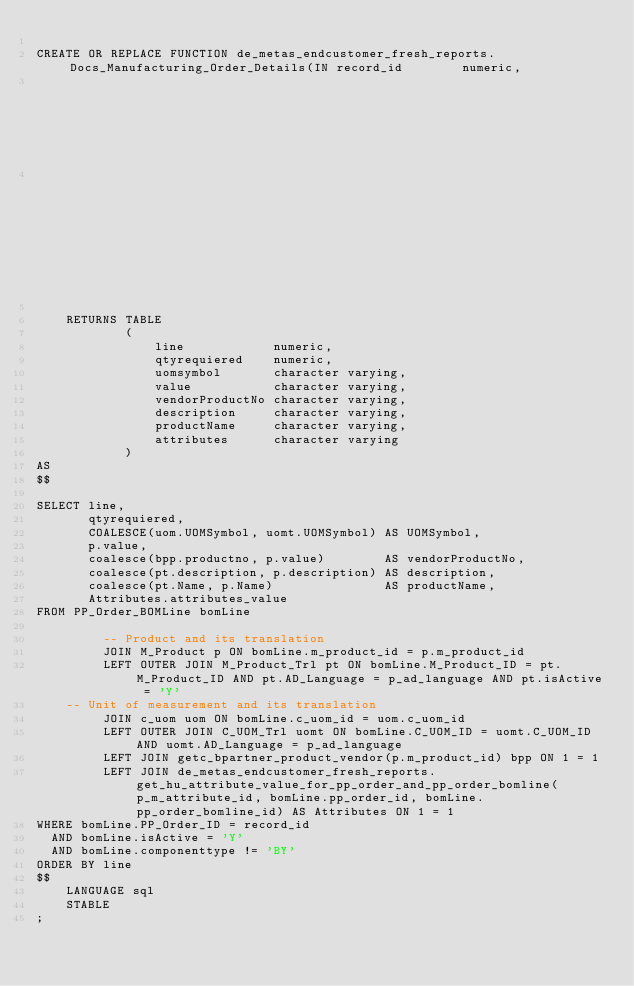<code> <loc_0><loc_0><loc_500><loc_500><_SQL_>
CREATE OR REPLACE FUNCTION de_metas_endcustomer_fresh_reports.Docs_Manufacturing_Order_Details(IN record_id        numeric,
                                                                                               IN p_m_attribute_id numeric,
                                                                                               IN p_ad_language    character Varying)

    RETURNS TABLE
            (
                line            numeric,
                qtyrequiered    numeric,
                uomsymbol       character varying,
                value           character varying,
                vendorProductNo character varying,
                description     character varying,
                productName     character varying,
                attributes      character varying
            )
AS
$$

SELECT line,
       qtyrequiered,
       COALESCE(uom.UOMSymbol, uomt.UOMSymbol) AS UOMSymbol,
       p.value,
       coalesce(bpp.productno, p.value)        AS vendorProductNo,
       coalesce(pt.description, p.description) AS description,
       coalesce(pt.Name, p.Name)               AS productName,
       Attributes.attributes_value
FROM PP_Order_BOMLine bomLine

         -- Product and its translation
         JOIN M_Product p ON bomLine.m_product_id = p.m_product_id
         LEFT OUTER JOIN M_Product_Trl pt ON bomLine.M_Product_ID = pt.M_Product_ID AND pt.AD_Language = p_ad_language AND pt.isActive = 'Y'
    -- Unit of measurement and its translation
         JOIN c_uom uom ON bomLine.c_uom_id = uom.c_uom_id
         LEFT OUTER JOIN C_UOM_Trl uomt ON bomLine.C_UOM_ID = uomt.C_UOM_ID AND uomt.AD_Language = p_ad_language
         LEFT JOIN getc_bpartner_product_vendor(p.m_product_id) bpp ON 1 = 1
         LEFT JOIN de_metas_endcustomer_fresh_reports.get_hu_attribute_value_for_pp_order_and_pp_order_bomline(p_m_attribute_id, bomLine.pp_order_id, bomLine.pp_order_bomline_id) AS Attributes ON 1 = 1
WHERE bomLine.PP_Order_ID = record_id
  AND bomLine.isActive = 'Y'
  AND bomLine.componenttype != 'BY'
ORDER BY line
$$
    LANGUAGE sql
    STABLE
;
</code> 